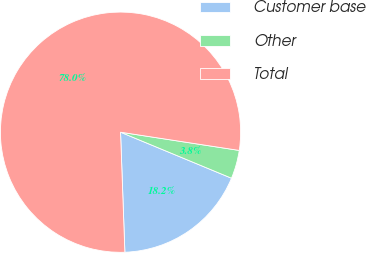<chart> <loc_0><loc_0><loc_500><loc_500><pie_chart><fcel>Customer base<fcel>Other<fcel>Total<nl><fcel>18.17%<fcel>3.83%<fcel>78.0%<nl></chart> 